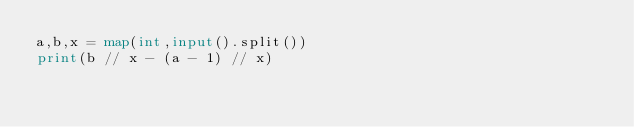<code> <loc_0><loc_0><loc_500><loc_500><_Python_>a,b,x = map(int,input().split())
print(b // x - (a - 1) // x)
</code> 